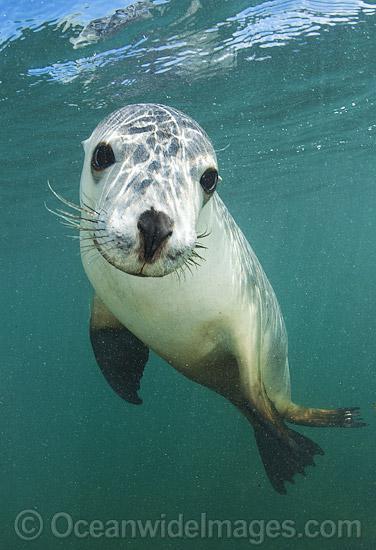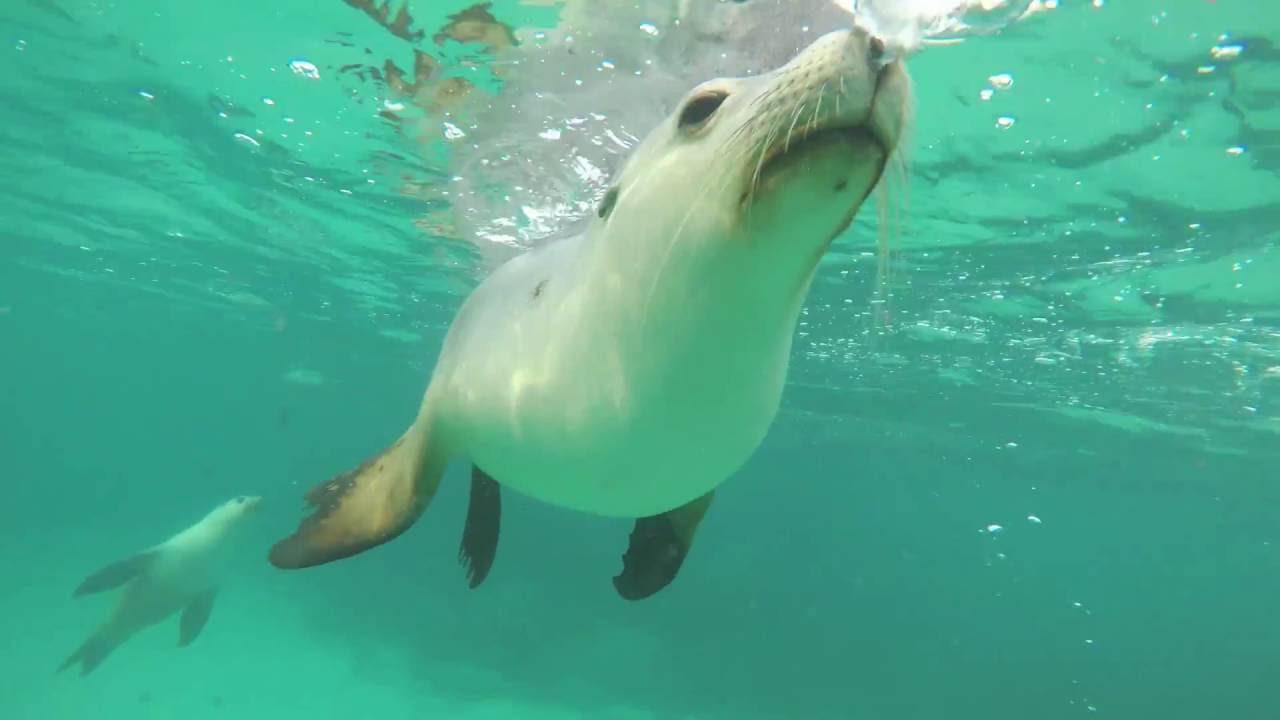The first image is the image on the left, the second image is the image on the right. For the images displayed, is the sentence "There are more than three seals in the water in the image on the right." factually correct? Answer yes or no. No. The first image is the image on the left, the second image is the image on the right. Examine the images to the left and right. Is the description "There is no more than two seals in the right image." accurate? Answer yes or no. Yes. 